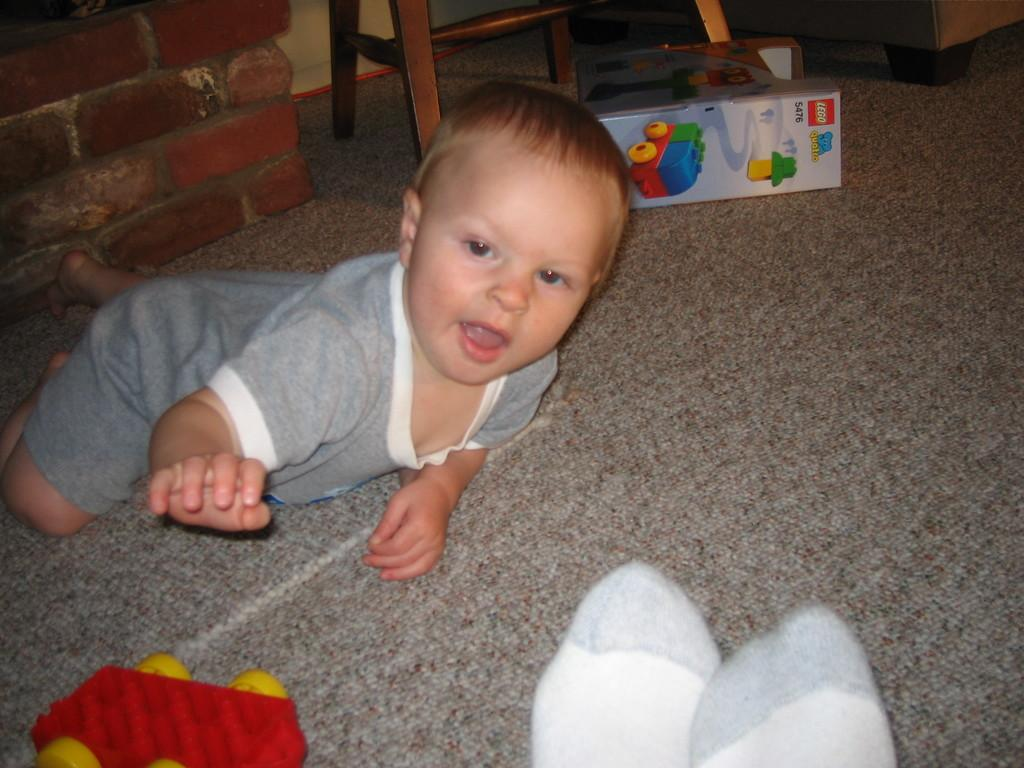What is the person in the image doing? The person is lying on the floor in the image. What else can be seen in the image besides the person? There are toys, a box, a chair, and a wall in the image. Can you describe the toys in the image? The toys are not specified, but they are present in the image. What is the purpose of the box in the image? The purpose of the box is not specified, but it is present in the image. Where is the nest located in the image? There is no nest present in the image. What note is the person holding in the image? There is no note present in the image. 